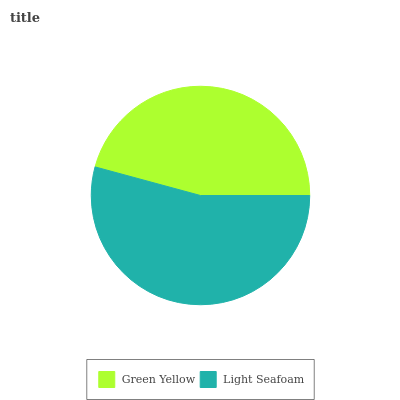Is Green Yellow the minimum?
Answer yes or no. Yes. Is Light Seafoam the maximum?
Answer yes or no. Yes. Is Light Seafoam the minimum?
Answer yes or no. No. Is Light Seafoam greater than Green Yellow?
Answer yes or no. Yes. Is Green Yellow less than Light Seafoam?
Answer yes or no. Yes. Is Green Yellow greater than Light Seafoam?
Answer yes or no. No. Is Light Seafoam less than Green Yellow?
Answer yes or no. No. Is Light Seafoam the high median?
Answer yes or no. Yes. Is Green Yellow the low median?
Answer yes or no. Yes. Is Green Yellow the high median?
Answer yes or no. No. Is Light Seafoam the low median?
Answer yes or no. No. 